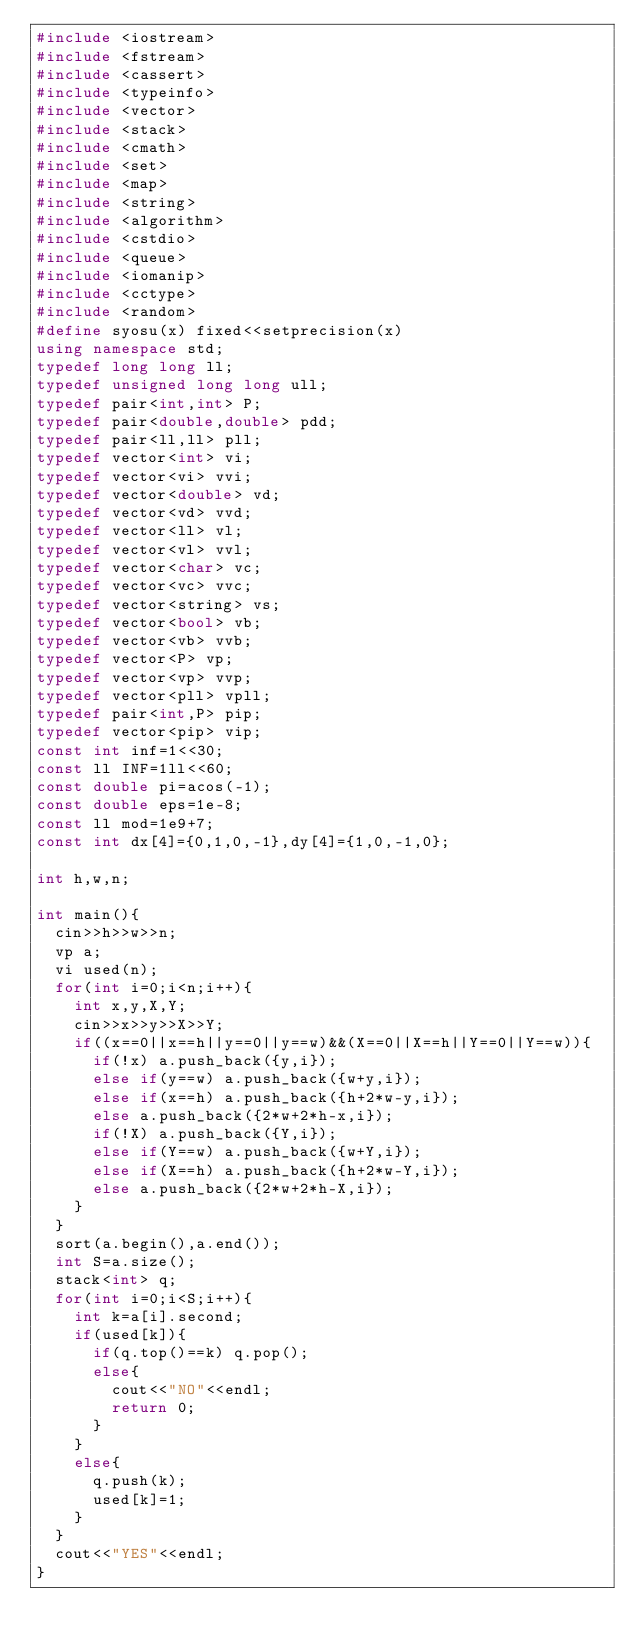Convert code to text. <code><loc_0><loc_0><loc_500><loc_500><_C++_>#include <iostream>
#include <fstream>
#include <cassert>
#include <typeinfo>
#include <vector>
#include <stack>
#include <cmath>
#include <set>
#include <map>
#include <string>
#include <algorithm>
#include <cstdio>
#include <queue>
#include <iomanip>
#include <cctype>
#include <random>
#define syosu(x) fixed<<setprecision(x)
using namespace std;
typedef long long ll;
typedef unsigned long long ull;
typedef pair<int,int> P;
typedef pair<double,double> pdd;
typedef pair<ll,ll> pll;
typedef vector<int> vi;
typedef vector<vi> vvi;
typedef vector<double> vd;
typedef vector<vd> vvd;
typedef vector<ll> vl;
typedef vector<vl> vvl;
typedef vector<char> vc;
typedef vector<vc> vvc;
typedef vector<string> vs;
typedef vector<bool> vb;
typedef vector<vb> vvb;
typedef vector<P> vp;
typedef vector<vp> vvp;
typedef vector<pll> vpll;
typedef pair<int,P> pip;
typedef vector<pip> vip;
const int inf=1<<30;
const ll INF=1ll<<60;
const double pi=acos(-1);
const double eps=1e-8;
const ll mod=1e9+7;
const int dx[4]={0,1,0,-1},dy[4]={1,0,-1,0};

int h,w,n;

int main(){
	cin>>h>>w>>n;
	vp a;
	vi used(n);
	for(int i=0;i<n;i++){
		int x,y,X,Y;
		cin>>x>>y>>X>>Y;
		if((x==0||x==h||y==0||y==w)&&(X==0||X==h||Y==0||Y==w)){
			if(!x) a.push_back({y,i});
			else if(y==w) a.push_back({w+y,i});
			else if(x==h) a.push_back({h+2*w-y,i});
			else a.push_back({2*w+2*h-x,i});		
			if(!X) a.push_back({Y,i});
			else if(Y==w) a.push_back({w+Y,i});
			else if(X==h) a.push_back({h+2*w-Y,i});
			else a.push_back({2*w+2*h-X,i});
		}
	}
	sort(a.begin(),a.end());
	int S=a.size();
	stack<int> q;
	for(int i=0;i<S;i++){
		int k=a[i].second;
		if(used[k]){
			if(q.top()==k) q.pop();
			else{
				cout<<"NO"<<endl;
				return 0;
			}
		}
		else{
			q.push(k);
			used[k]=1;
		}
	}
	cout<<"YES"<<endl;
}</code> 